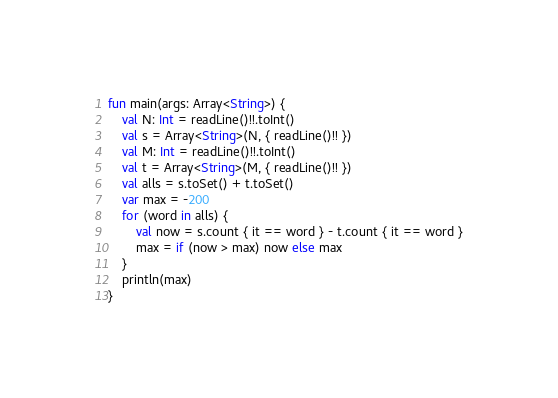<code> <loc_0><loc_0><loc_500><loc_500><_Kotlin_>fun main(args: Array<String>) {
    val N: Int = readLine()!!.toInt()
    val s = Array<String>(N, { readLine()!! })
    val M: Int = readLine()!!.toInt()
    val t = Array<String>(M, { readLine()!! })
    val alls = s.toSet() + t.toSet()
    var max = -200
    for (word in alls) {
        val now = s.count { it == word } - t.count { it == word }
        max = if (now > max) now else max
    }
    println(max)
}
</code> 